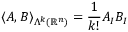Convert formula to latex. <formula><loc_0><loc_0><loc_500><loc_500>\langle A , B \rangle _ { \Lambda ^ { k } ( \mathbb { R } ^ { n } ) } = \frac { 1 } { k ! } A _ { I } B _ { I }</formula> 